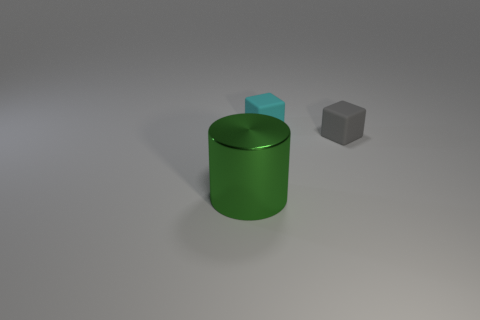Is there any other thing that has the same size as the green metallic cylinder?
Provide a succinct answer. No. The cyan thing has what size?
Offer a terse response. Small. Is the number of tiny objects to the left of the green shiny cylinder greater than the number of tiny cyan rubber things to the right of the gray block?
Provide a short and direct response. No. There is a small thing right of the cyan thing; how many green things are behind it?
Make the answer very short. 0. There is a matte object behind the gray matte block; does it have the same shape as the gray object?
Make the answer very short. Yes. There is a small gray thing that is the same shape as the cyan object; what is its material?
Give a very brief answer. Rubber. How many gray objects are the same size as the gray rubber cube?
Your answer should be compact. 0. What color is the object that is both behind the shiny cylinder and in front of the cyan cube?
Your response must be concise. Gray. Is the number of cubes less than the number of cyan blocks?
Provide a short and direct response. No. There is a shiny cylinder; does it have the same color as the matte block that is right of the cyan thing?
Your answer should be compact. No. 